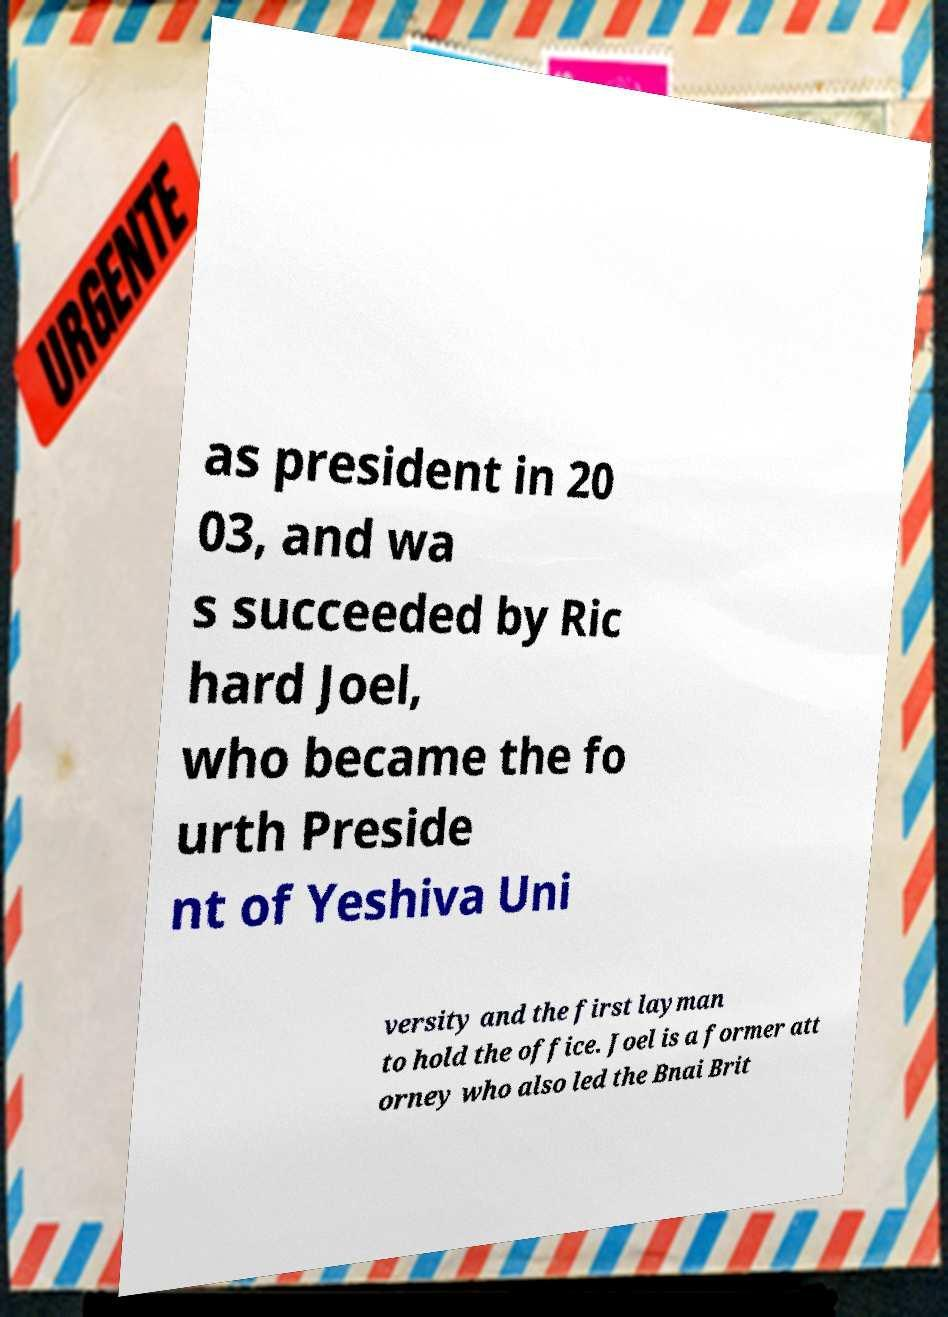Can you read and provide the text displayed in the image?This photo seems to have some interesting text. Can you extract and type it out for me? as president in 20 03, and wa s succeeded by Ric hard Joel, who became the fo urth Preside nt of Yeshiva Uni versity and the first layman to hold the office. Joel is a former att orney who also led the Bnai Brit 